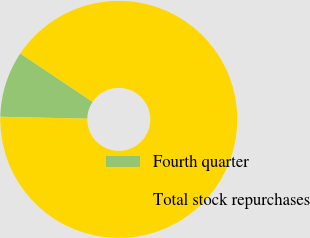Convert chart. <chart><loc_0><loc_0><loc_500><loc_500><pie_chart><fcel>Fourth quarter<fcel>Total stock repurchases<nl><fcel>9.03%<fcel>90.97%<nl></chart> 